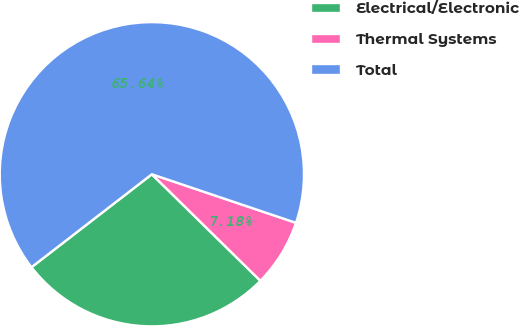Convert chart. <chart><loc_0><loc_0><loc_500><loc_500><pie_chart><fcel>Electrical/Electronic<fcel>Thermal Systems<fcel>Total<nl><fcel>27.18%<fcel>7.18%<fcel>65.64%<nl></chart> 